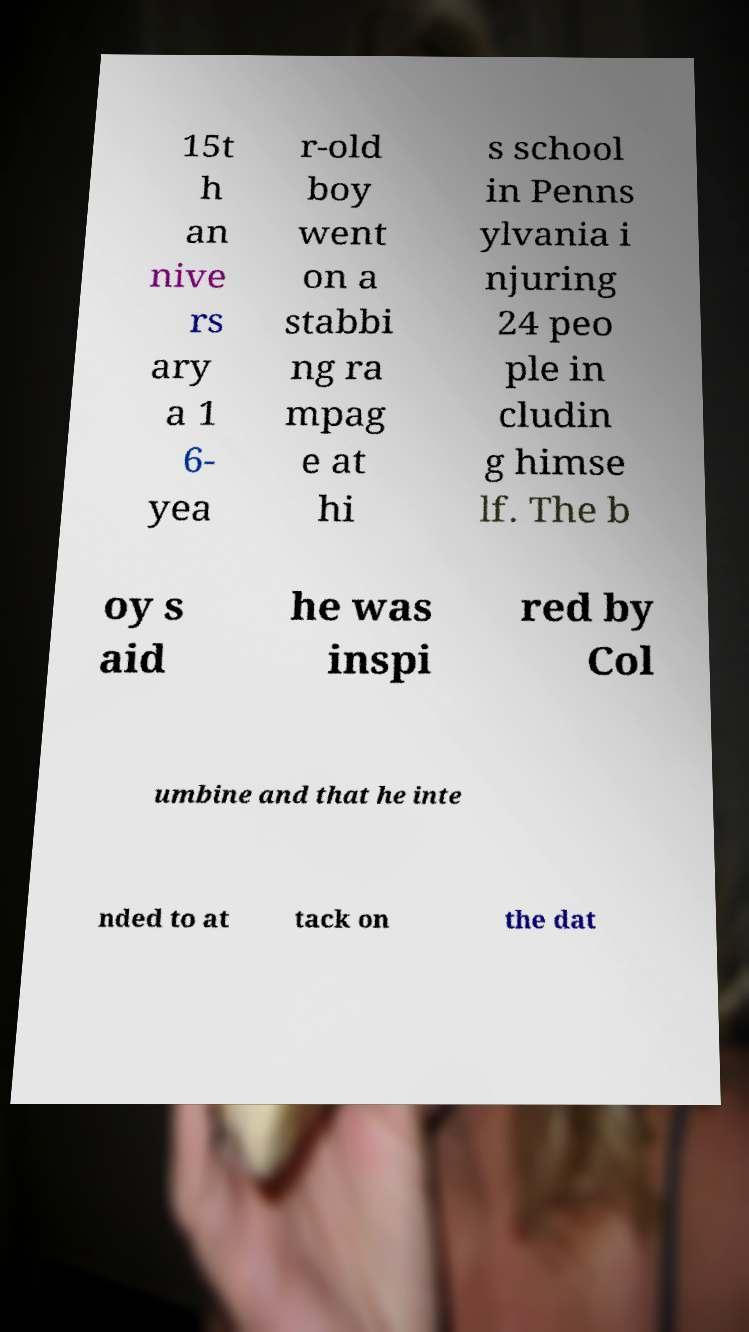There's text embedded in this image that I need extracted. Can you transcribe it verbatim? 15t h an nive rs ary a 1 6- yea r-old boy went on a stabbi ng ra mpag e at hi s school in Penns ylvania i njuring 24 peo ple in cludin g himse lf. The b oy s aid he was inspi red by Col umbine and that he inte nded to at tack on the dat 